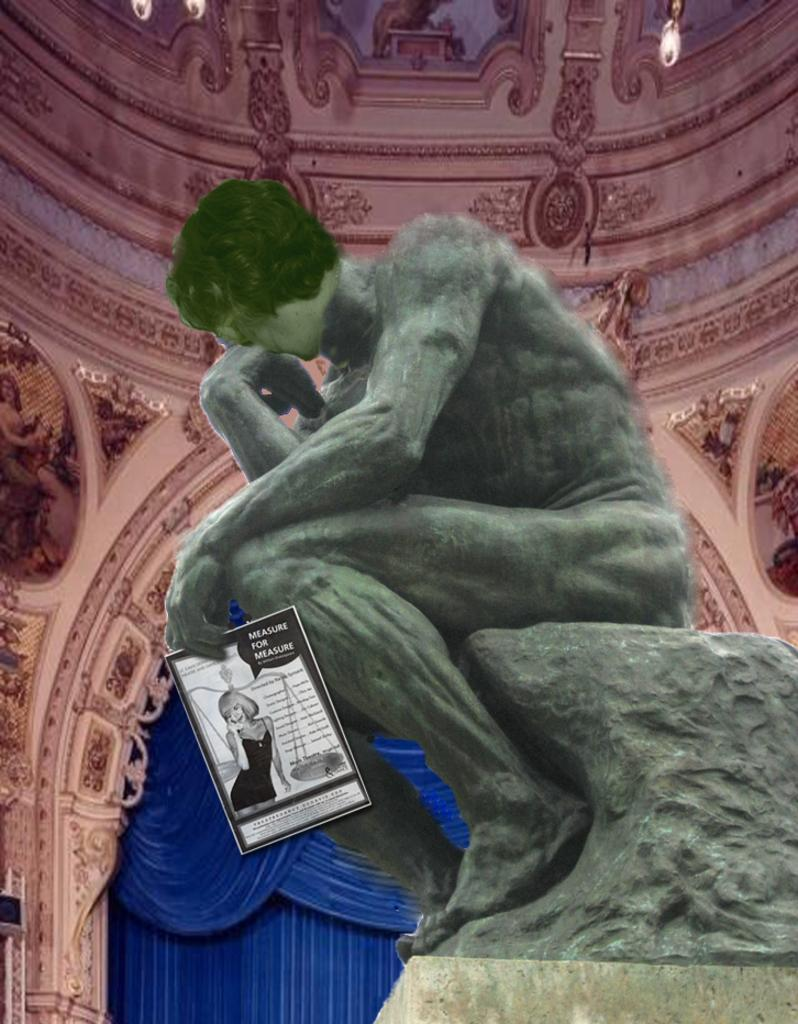What is the main subject of the image? There is a statue of a human being in the image. What can be said about the color of the statue? The statue is green in color. What other object can be seen in the image? There is a poster in the image. What can be seen in the background of the image? There is a pink color parish building in the background of the image. What type of creature is playing volleyball in the image? There is no creature playing volleyball in the image; it only features a statue of a human being, a poster, and a pink color parish building in the background. 